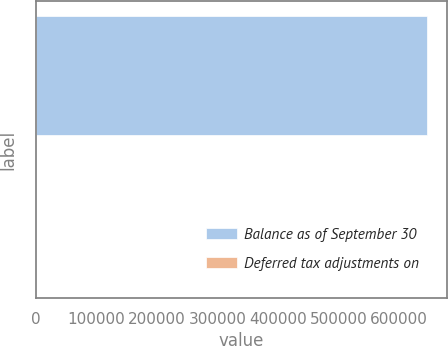Convert chart. <chart><loc_0><loc_0><loc_500><loc_500><bar_chart><fcel>Balance as of September 30<fcel>Deferred tax adjustments on<nl><fcel>646076<fcel>262<nl></chart> 